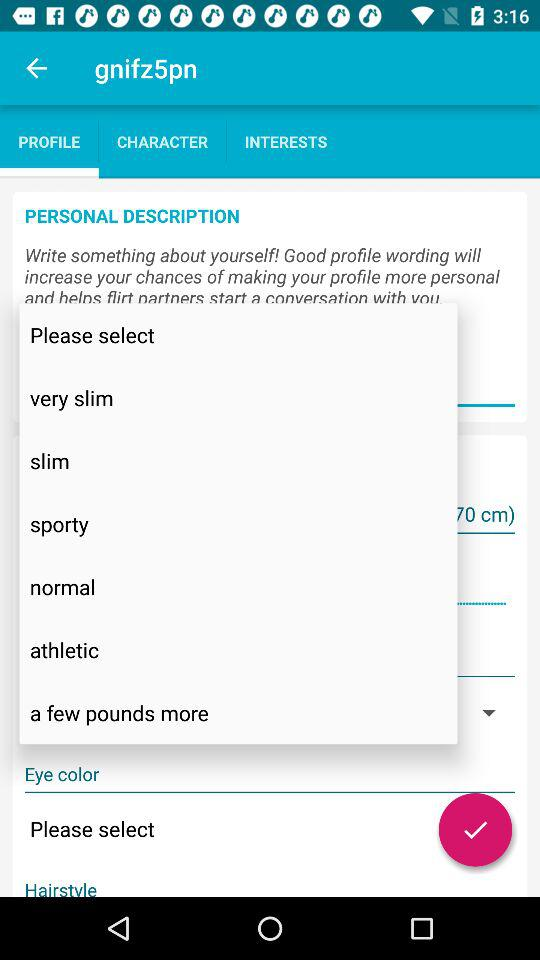What is the app name? The app name is "gnifz5pn". 